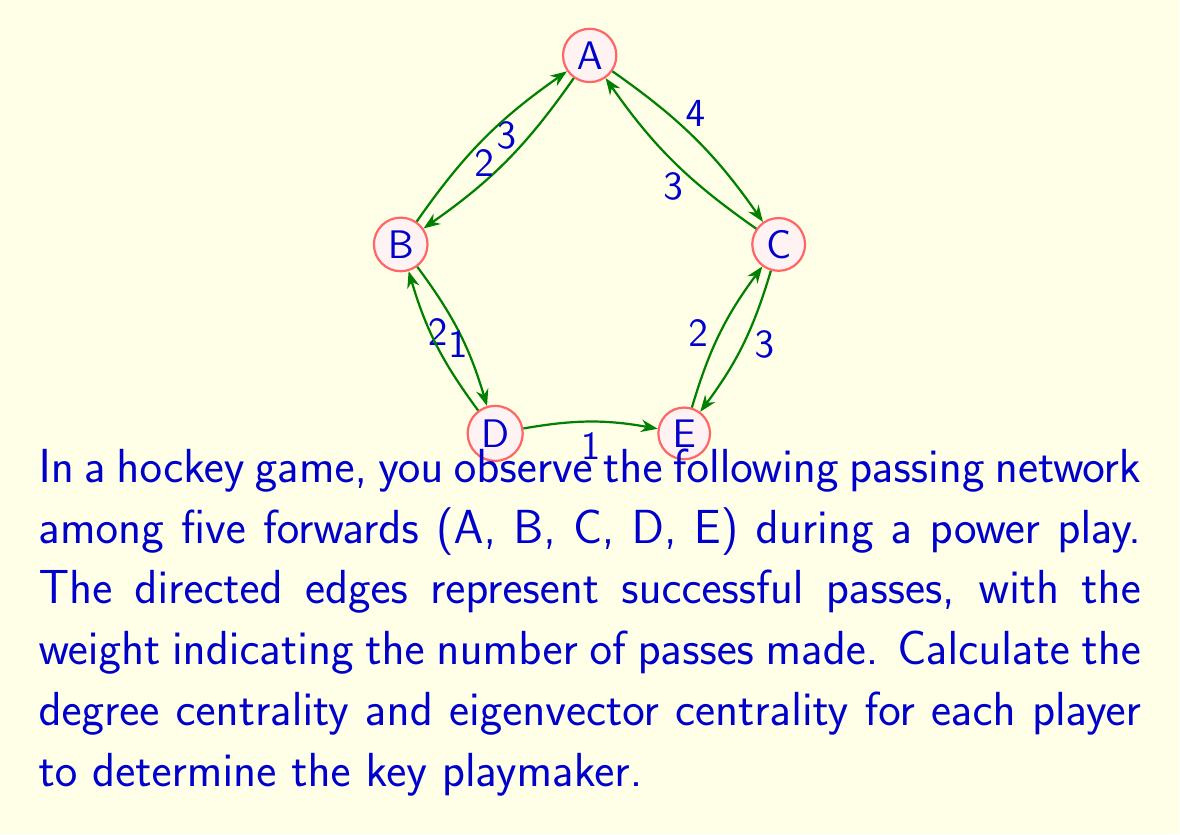Give your solution to this math problem. To identify the key playmaker, we'll calculate two centrality measures: degree centrality and eigenvector centrality.

1. Degree Centrality:
Degree centrality measures the number of connections a node has. In a directed graph, we consider both in-degree and out-degree.

For each player:
A: In-degree = 5, Out-degree = 7
B: In-degree = 3, Out-degree = 5
C: In-degree = 7, Out-degree = 6
D: In-degree = 3, Out-degree = 2
E: In-degree = 3, Out-degree = 1

Total degree centrality:
A: 5 + 7 = 12
B: 3 + 5 = 8
C: 7 + 6 = 13
D: 3 + 2 = 5
E: 3 + 1 = 4

2. Eigenvector Centrality:
Eigenvector centrality considers not only the number of connections but also the importance of those connections. We'll use the power iteration method to approximate the eigenvector centrality.

Step 1: Create the adjacency matrix A:
$$A = \begin{bmatrix}
0 & 3 & 4 & 0 & 0 \\
2 & 0 & 0 & 2 & 0 \\
3 & 0 & 0 & 0 & 3 \\
0 & 1 & 0 & 0 & 1 \\
0 & 0 & 2 & 0 & 0
\end{bmatrix}$$

Step 2: Initialize a vector x with all 1's:
$$x_0 = \begin{bmatrix} 1 \\ 1 \\ 1 \\ 1 \\ 1 \end{bmatrix}$$

Step 3: Iterate using the formula $x_{k+1} = \frac{Ax_k}{||Ax_k||}$ until convergence:

After several iterations, we get:
$$x \approx \begin{bmatrix} 0.5226 \\ 0.3140 \\ 0.5226 \\ 0.1570 \\ 0.1570 \end{bmatrix}$$

These values represent the relative eigenvector centrality scores for players A, B, C, D, and E, respectively.

Based on both centrality measures, player C appears to be the key playmaker, followed closely by player A.
Answer: Key playmaker: Player C

Degree Centrality:
A: 12
B: 8
C: 13
D: 5
E: 4

Eigenvector Centrality (approximated):
A: 0.5226
B: 0.3140
C: 0.5226
D: 0.1570
E: 0.1570 